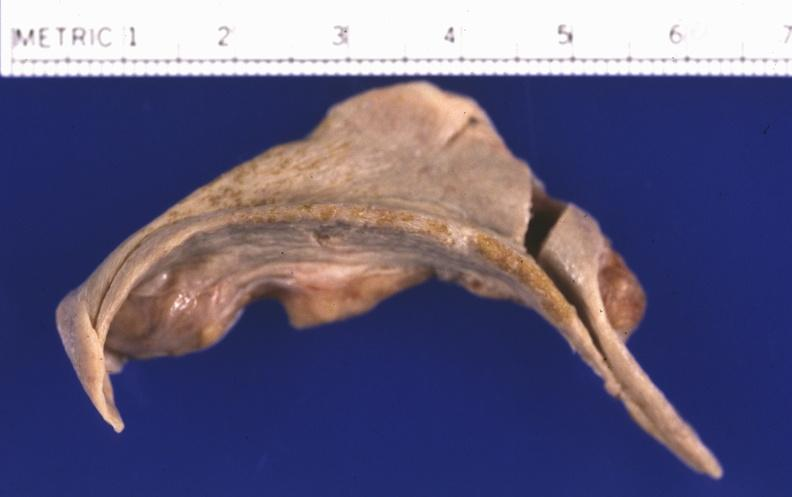where is this part in?
Answer the question using a single word or phrase. Spleen 